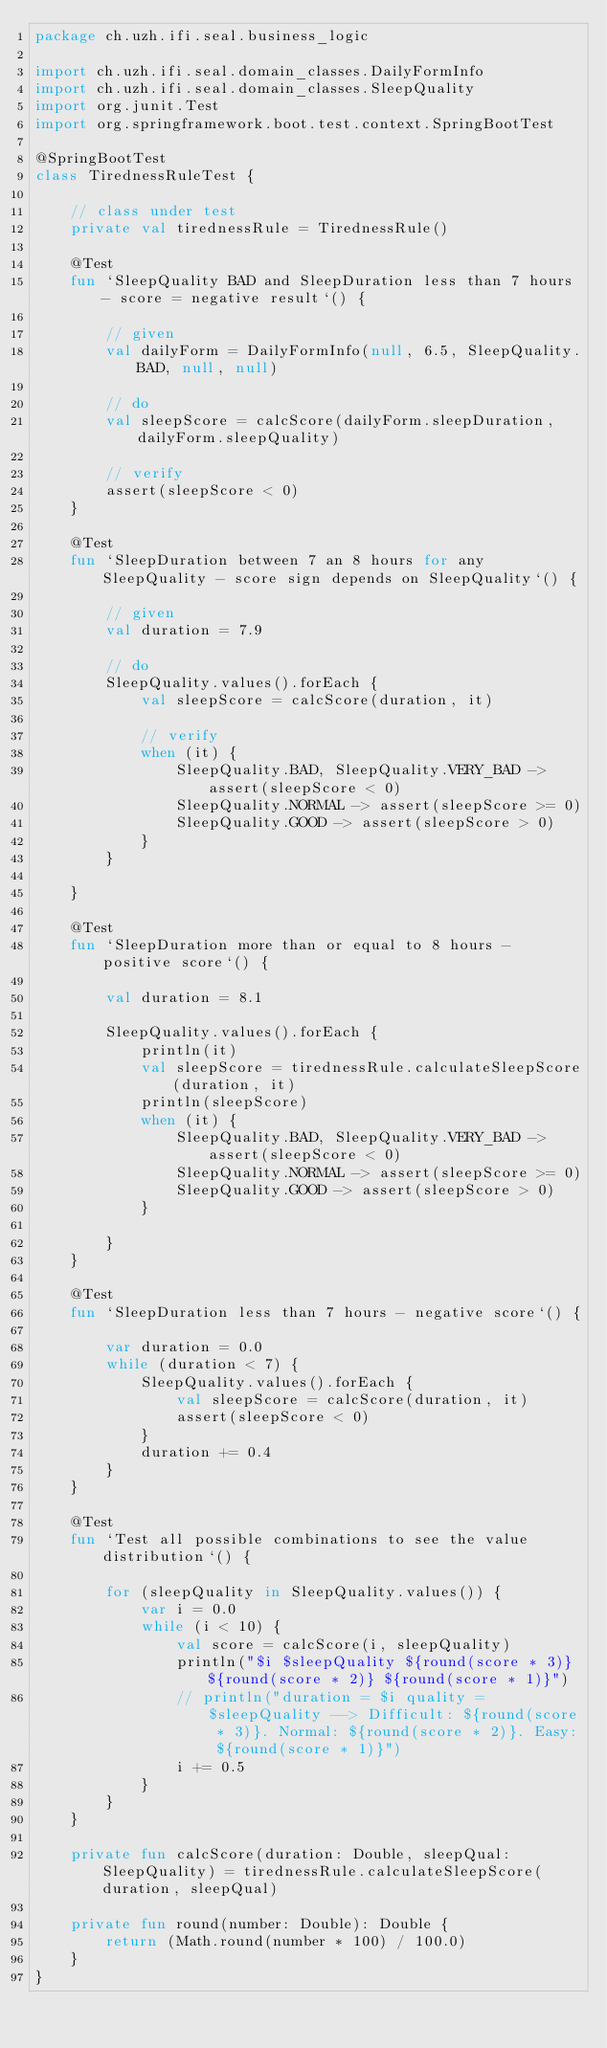<code> <loc_0><loc_0><loc_500><loc_500><_Kotlin_>package ch.uzh.ifi.seal.business_logic

import ch.uzh.ifi.seal.domain_classes.DailyFormInfo
import ch.uzh.ifi.seal.domain_classes.SleepQuality
import org.junit.Test
import org.springframework.boot.test.context.SpringBootTest

@SpringBootTest
class TirednessRuleTest {

    // class under test
    private val tirednessRule = TirednessRule()

    @Test
    fun `SleepQuality BAD and SleepDuration less than 7 hours - score = negative result`() {

        // given
        val dailyForm = DailyFormInfo(null, 6.5, SleepQuality.BAD, null, null)

        // do
        val sleepScore = calcScore(dailyForm.sleepDuration, dailyForm.sleepQuality)

        // verify
        assert(sleepScore < 0)
    }

    @Test
    fun `SleepDuration between 7 an 8 hours for any SleepQuality - score sign depends on SleepQuality`() {

        // given
        val duration = 7.9

        // do
        SleepQuality.values().forEach {
            val sleepScore = calcScore(duration, it)

            // verify
            when (it) {
                SleepQuality.BAD, SleepQuality.VERY_BAD -> assert(sleepScore < 0)
                SleepQuality.NORMAL -> assert(sleepScore >= 0)
                SleepQuality.GOOD -> assert(sleepScore > 0)
            }
        }

    }

    @Test
    fun `SleepDuration more than or equal to 8 hours - positive score`() {

        val duration = 8.1

        SleepQuality.values().forEach {
            println(it)
            val sleepScore = tirednessRule.calculateSleepScore(duration, it)
            println(sleepScore)
            when (it) {
                SleepQuality.BAD, SleepQuality.VERY_BAD -> assert(sleepScore < 0)
                SleepQuality.NORMAL -> assert(sleepScore >= 0)
                SleepQuality.GOOD -> assert(sleepScore > 0)
            }

        }
    }

    @Test
    fun `SleepDuration less than 7 hours - negative score`() {

        var duration = 0.0
        while (duration < 7) {
            SleepQuality.values().forEach {
                val sleepScore = calcScore(duration, it)
                assert(sleepScore < 0)
            }
            duration += 0.4
        }
    }

    @Test
    fun `Test all possible combinations to see the value distribution`() {

        for (sleepQuality in SleepQuality.values()) {
            var i = 0.0
            while (i < 10) {
                val score = calcScore(i, sleepQuality)
                println("$i $sleepQuality ${round(score * 3)} ${round(score * 2)} ${round(score * 1)}")
                // println("duration = $i quality = $sleepQuality --> Difficult: ${round(score * 3)}. Normal: ${round(score * 2)}. Easy: ${round(score * 1)}")
                i += 0.5
            }
        }
    }

    private fun calcScore(duration: Double, sleepQual: SleepQuality) = tirednessRule.calculateSleepScore(duration, sleepQual)

    private fun round(number: Double): Double {
        return (Math.round(number * 100) / 100.0)
    }
}</code> 